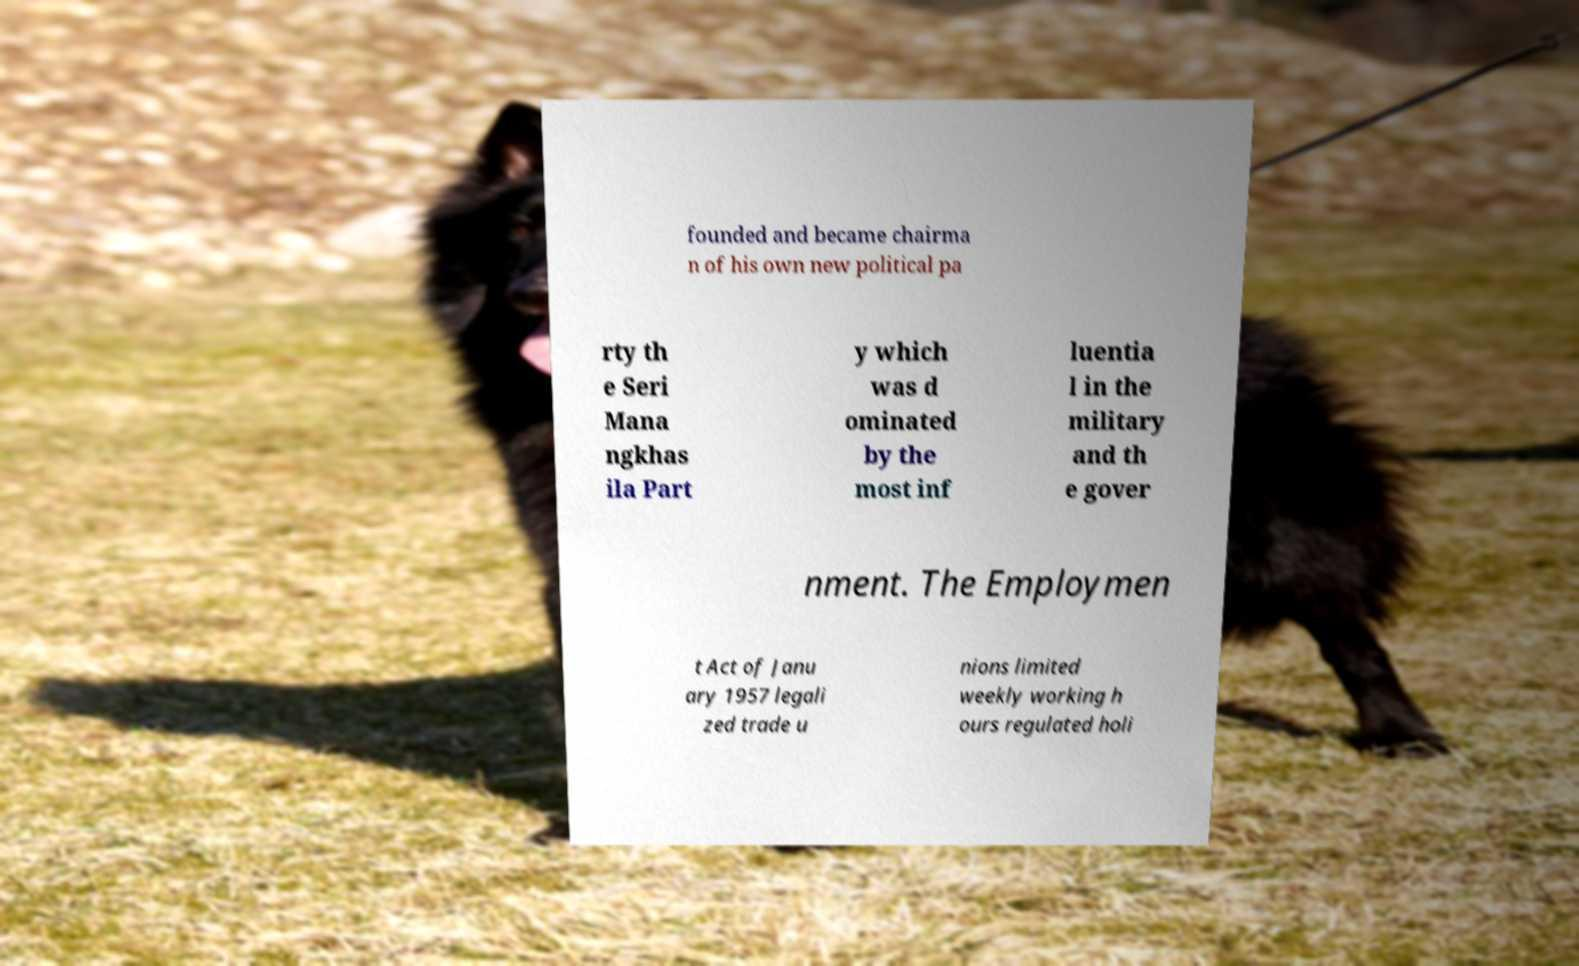Can you accurately transcribe the text from the provided image for me? founded and became chairma n of his own new political pa rty th e Seri Mana ngkhas ila Part y which was d ominated by the most inf luentia l in the military and th e gover nment. The Employmen t Act of Janu ary 1957 legali zed trade u nions limited weekly working h ours regulated holi 